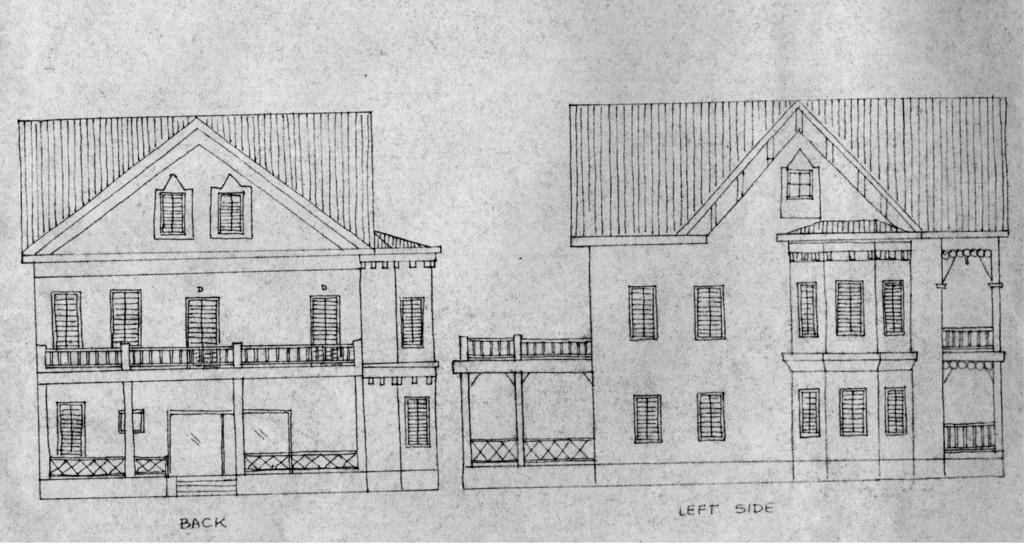What is depicted in the image? There is a drawing of houses in the image. Are there any words or letters in the image? Yes, there is text in the image. What type of cattle can be seen grazing in the image? There are no cattle present in the image; it features a drawing of houses and text. 